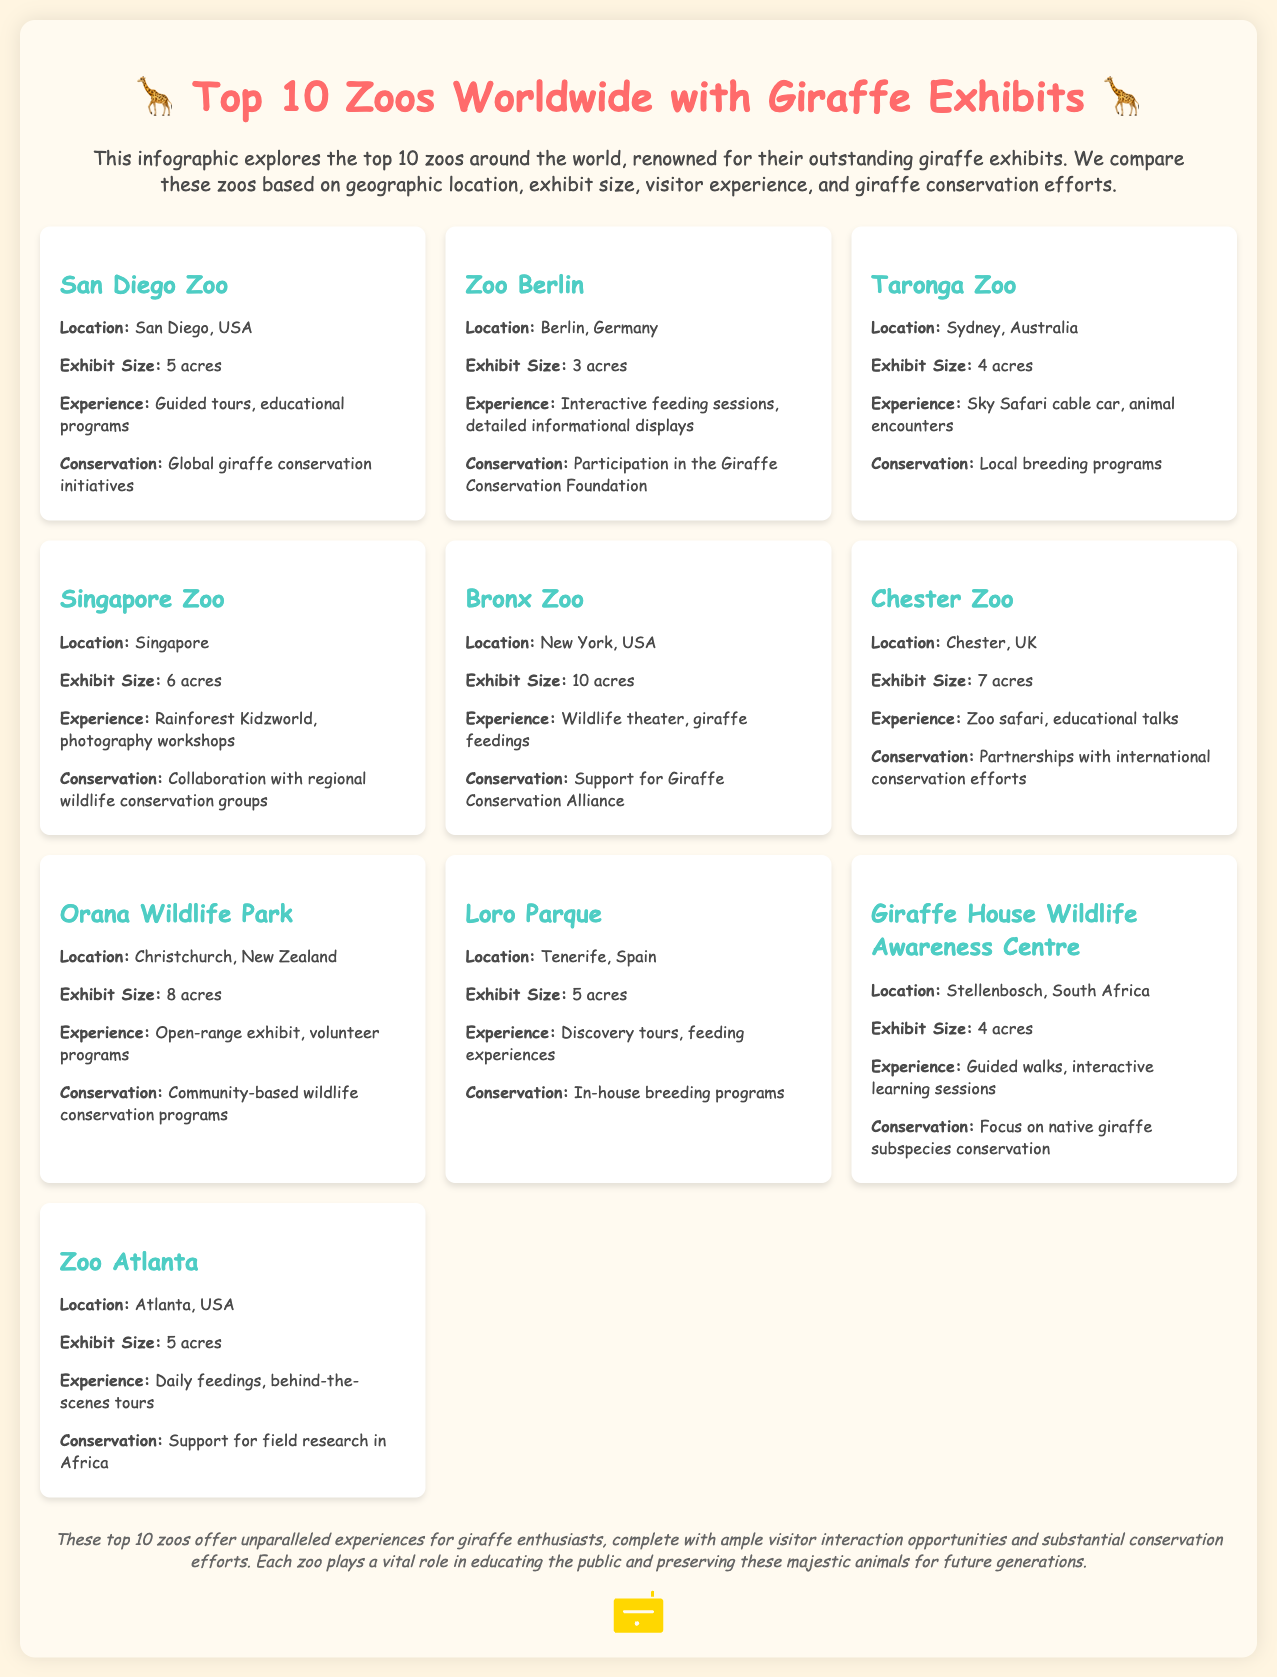What is the location of the San Diego Zoo? The San Diego Zoo is located in San Diego, USA, as stated in the document.
Answer: San Diego, USA How large is the exhibit at Zoo Berlin? The document specifies that the exhibit size at Zoo Berlin is 3 acres.
Answer: 3 acres Which zoo offers a Sky Safari cable car experience? The document states that Taronga Zoo provides a Sky Safari cable car experience.
Answer: Taronga Zoo What type of conservation does Chester Zoo participate in? Chester Zoo is involved in partnerships with international conservation efforts, as mentioned in the description.
Answer: International conservation efforts Which zoo has the largest exhibit size? According to the document, the Bronx Zoo has the largest exhibit size at 10 acres.
Answer: 10 acres Which zoo is located in New York? The Bronx Zoo is identified as being located in New York, USA, in the document.
Answer: Bronx Zoo What unique experience does the Singapore Zoo offer? The document mentions that Singapore Zoo offers Rainforest Kidzworld and photography workshops.
Answer: Rainforest Kidzworld, photography workshops What common aspect do all top 10 zoos provide regarding giraffes? The document emphasizes that all zoos play a vital role in educating the public on giraffe conservation.
Answer: Education on giraffe conservation Which zoo focuses on native giraffe subspecies conservation? The Giraffe House Wildlife Awareness Centre is specified as focusing on native giraffe subspecies conservation.
Answer: Giraffe House Wildlife Awareness Centre 